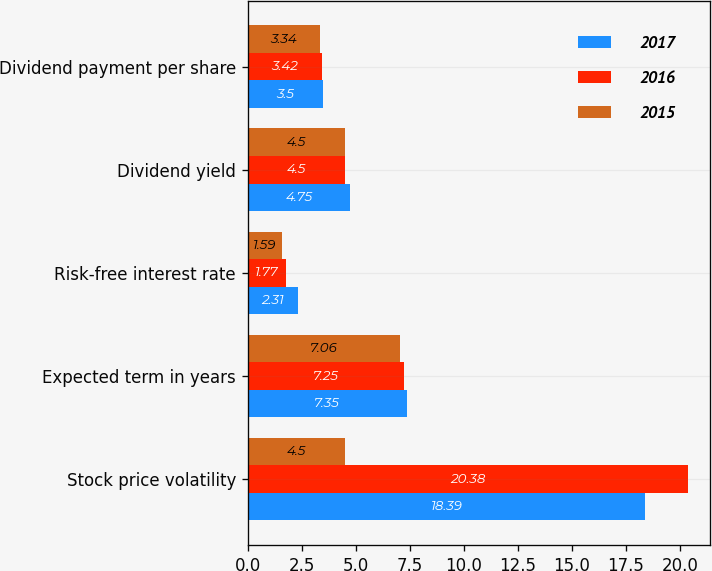Convert chart. <chart><loc_0><loc_0><loc_500><loc_500><stacked_bar_chart><ecel><fcel>Stock price volatility<fcel>Expected term in years<fcel>Risk-free interest rate<fcel>Dividend yield<fcel>Dividend payment per share<nl><fcel>2017<fcel>18.39<fcel>7.35<fcel>2.31<fcel>4.75<fcel>3.5<nl><fcel>2016<fcel>20.38<fcel>7.25<fcel>1.77<fcel>4.5<fcel>3.42<nl><fcel>2015<fcel>4.5<fcel>7.06<fcel>1.59<fcel>4.5<fcel>3.34<nl></chart> 